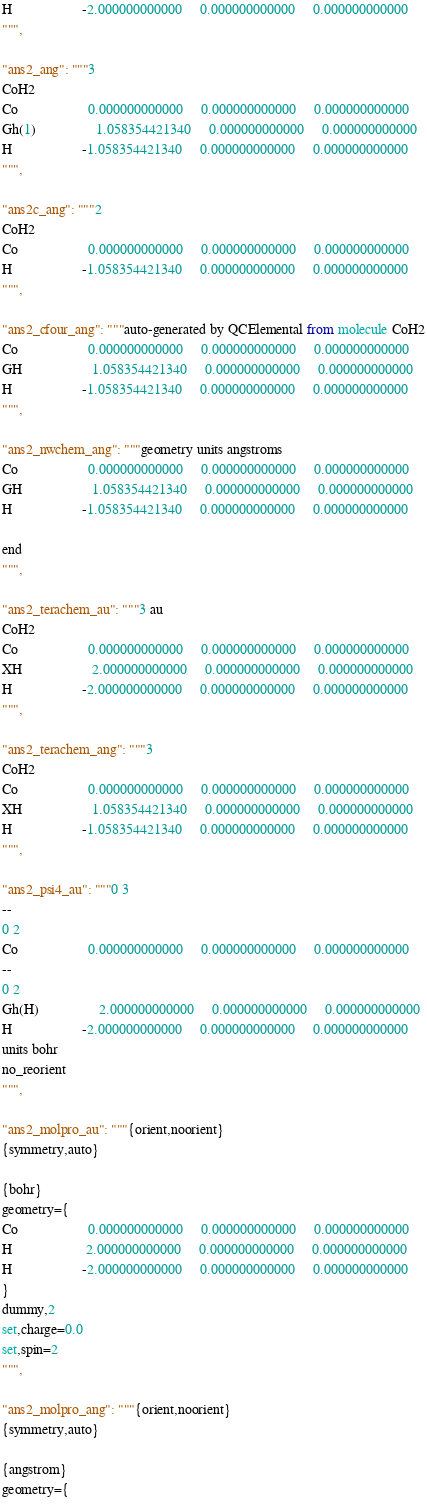<code> <loc_0><loc_0><loc_500><loc_500><_Python_>H                    -2.000000000000     0.000000000000     0.000000000000
""",

"ans2_ang": """3
CoH2
Co                    0.000000000000     0.000000000000     0.000000000000
Gh(1)                 1.058354421340     0.000000000000     0.000000000000
H                    -1.058354421340     0.000000000000     0.000000000000
""",

"ans2c_ang": """2
CoH2
Co                    0.000000000000     0.000000000000     0.000000000000
H                    -1.058354421340     0.000000000000     0.000000000000
""",

"ans2_cfour_ang": """auto-generated by QCElemental from molecule CoH2
Co                    0.000000000000     0.000000000000     0.000000000000
GH                    1.058354421340     0.000000000000     0.000000000000
H                    -1.058354421340     0.000000000000     0.000000000000
""",

"ans2_nwchem_ang": """geometry units angstroms
Co                    0.000000000000     0.000000000000     0.000000000000
GH                    1.058354421340     0.000000000000     0.000000000000
H                    -1.058354421340     0.000000000000     0.000000000000

end
""",

"ans2_terachem_au": """3 au
CoH2
Co                    0.000000000000     0.000000000000     0.000000000000
XH                    2.000000000000     0.000000000000     0.000000000000
H                    -2.000000000000     0.000000000000     0.000000000000
""",

"ans2_terachem_ang": """3
CoH2
Co                    0.000000000000     0.000000000000     0.000000000000
XH                    1.058354421340     0.000000000000     0.000000000000
H                    -1.058354421340     0.000000000000     0.000000000000
""",

"ans2_psi4_au": """0 3
--
0 2
Co                    0.000000000000     0.000000000000     0.000000000000
--
0 2
Gh(H)                 2.000000000000     0.000000000000     0.000000000000
H                    -2.000000000000     0.000000000000     0.000000000000
units bohr
no_reorient
""",

"ans2_molpro_au": """{orient,noorient}
{symmetry,auto}

{bohr}
geometry={
Co                    0.000000000000     0.000000000000     0.000000000000
H                     2.000000000000     0.000000000000     0.000000000000
H                    -2.000000000000     0.000000000000     0.000000000000
}
dummy,2
set,charge=0.0
set,spin=2
""",

"ans2_molpro_ang": """{orient,noorient}
{symmetry,auto}

{angstrom}
geometry={</code> 